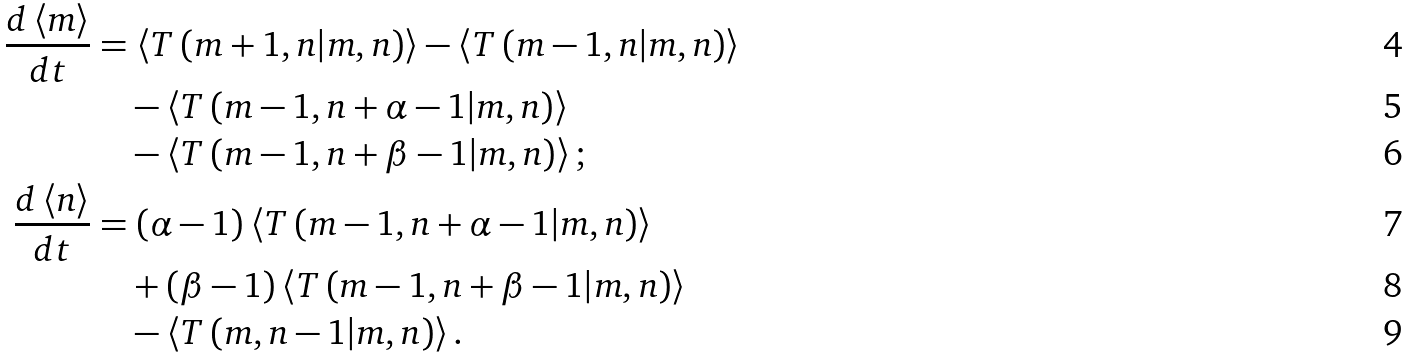<formula> <loc_0><loc_0><loc_500><loc_500>\frac { d \left \langle m \right \rangle } { d t } & = \left \langle T \left ( m + 1 , n | m , n \right ) \right \rangle - \left \langle T \left ( m - 1 , n | m , n \right ) \right \rangle \\ & \quad - \left \langle T \left ( m - 1 , n + \alpha - 1 | m , n \right ) \right \rangle \\ & \quad - \left \langle T \left ( m - 1 , n + \beta - 1 | m , n \right ) \right \rangle ; \\ \frac { d \left \langle n \right \rangle } { d t } & = \left ( \alpha - 1 \right ) \left \langle T \left ( m - 1 , n + \alpha - 1 | m , n \right ) \right \rangle \\ & \quad + \left ( \beta - 1 \right ) \left \langle T \left ( m - 1 , n + \beta - 1 | m , n \right ) \right \rangle \\ & \quad - \left \langle T \left ( m , n - 1 | m , n \right ) \right \rangle .</formula> 